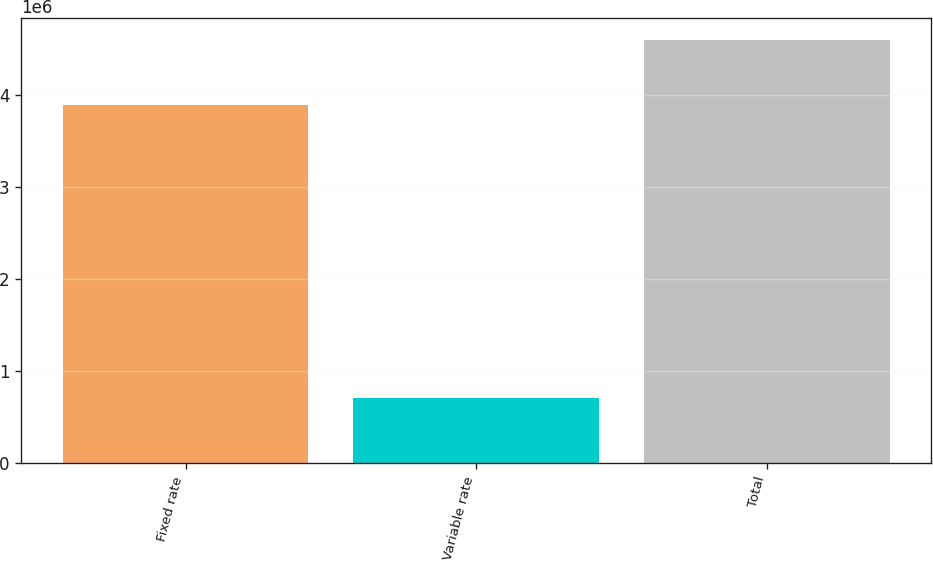<chart> <loc_0><loc_0><loc_500><loc_500><bar_chart><fcel>Fixed rate<fcel>Variable rate<fcel>Total<nl><fcel>3.88945e+06<fcel>711490<fcel>4.60094e+06<nl></chart> 